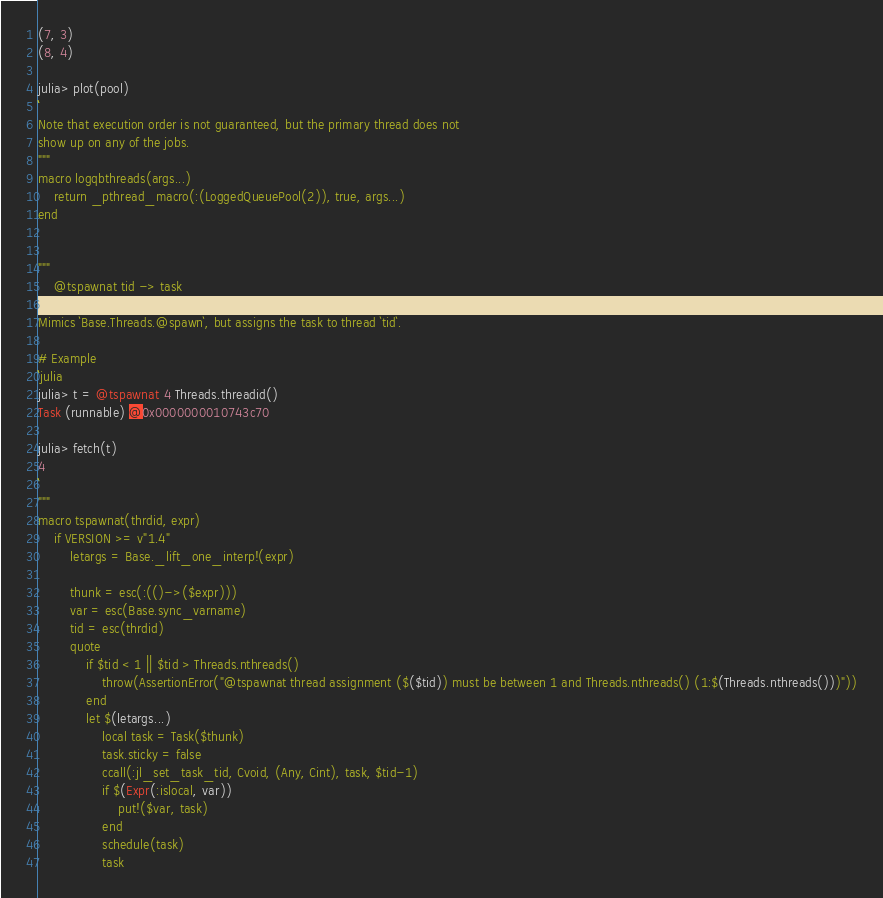<code> <loc_0><loc_0><loc_500><loc_500><_Julia_>(7, 3)
(8, 4)

julia> plot(pool)
```
Note that execution order is not guaranteed, but the primary thread does not
show up on any of the jobs.
"""
macro logqbthreads(args...) 
    return _pthread_macro(:(LoggedQueuePool(2)), true, args...)
end


"""
    @tspawnat tid -> task

Mimics `Base.Threads.@spawn`, but assigns the task to thread `tid`.

# Example
```julia
julia> t = @tspawnat 4 Threads.threadid()
Task (runnable) @0x0000000010743c70

julia> fetch(t)
4
```
"""
macro tspawnat(thrdid, expr)
    if VERSION >= v"1.4"
        letargs = Base._lift_one_interp!(expr)
    
        thunk = esc(:(()->($expr)))
        var = esc(Base.sync_varname)
        tid = esc(thrdid)
        quote
            if $tid < 1 || $tid > Threads.nthreads()
                throw(AssertionError("@tspawnat thread assignment ($($tid)) must be between 1 and Threads.nthreads() (1:$(Threads.nthreads()))"))
            end
            let $(letargs...)
                local task = Task($thunk)
                task.sticky = false
                ccall(:jl_set_task_tid, Cvoid, (Any, Cint), task, $tid-1)
                if $(Expr(:islocal, var))
                    put!($var, task)
                end
                schedule(task)
                task</code> 